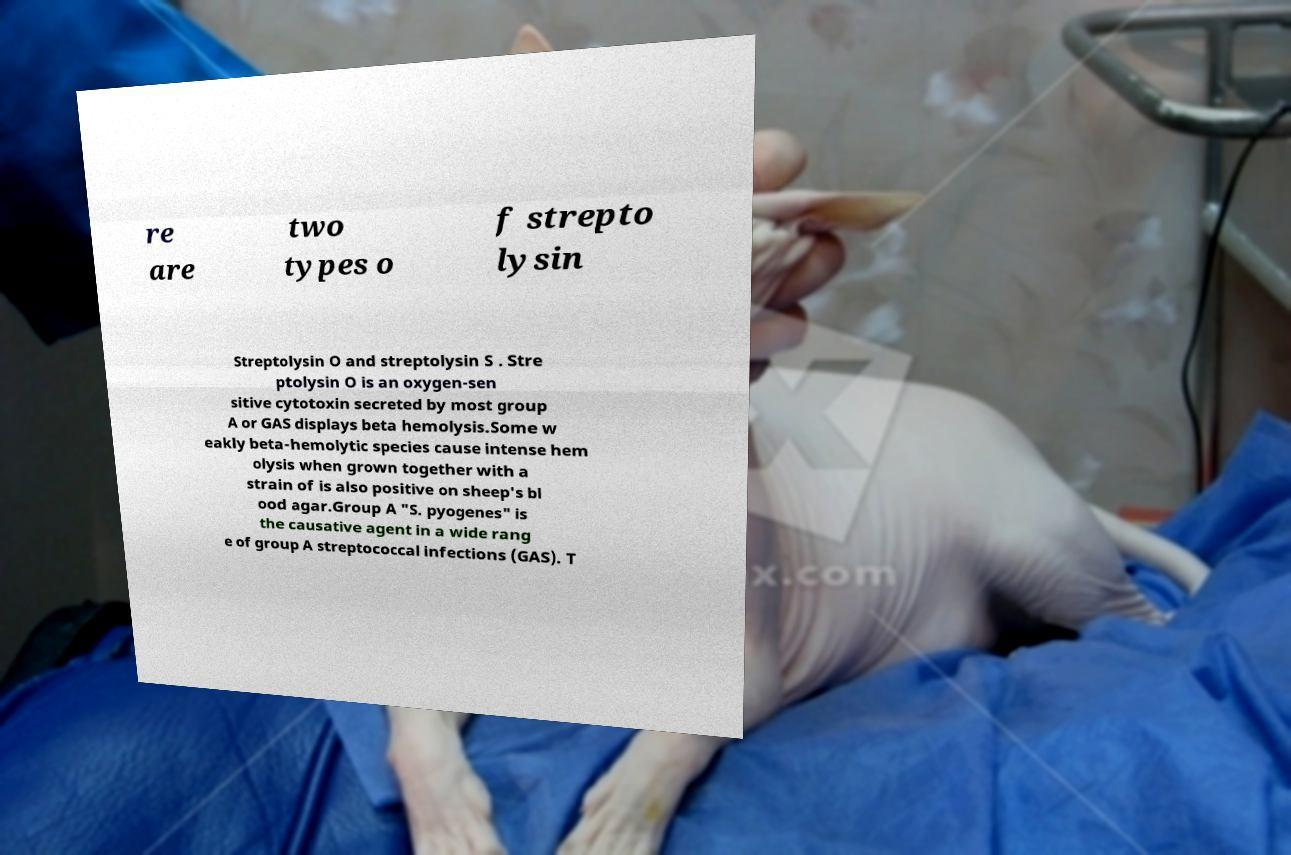Please identify and transcribe the text found in this image. re are two types o f strepto lysin Streptolysin O and streptolysin S . Stre ptolysin O is an oxygen-sen sitive cytotoxin secreted by most group A or GAS displays beta hemolysis.Some w eakly beta-hemolytic species cause intense hem olysis when grown together with a strain of is also positive on sheep's bl ood agar.Group A "S. pyogenes" is the causative agent in a wide rang e of group A streptococcal infections (GAS). T 